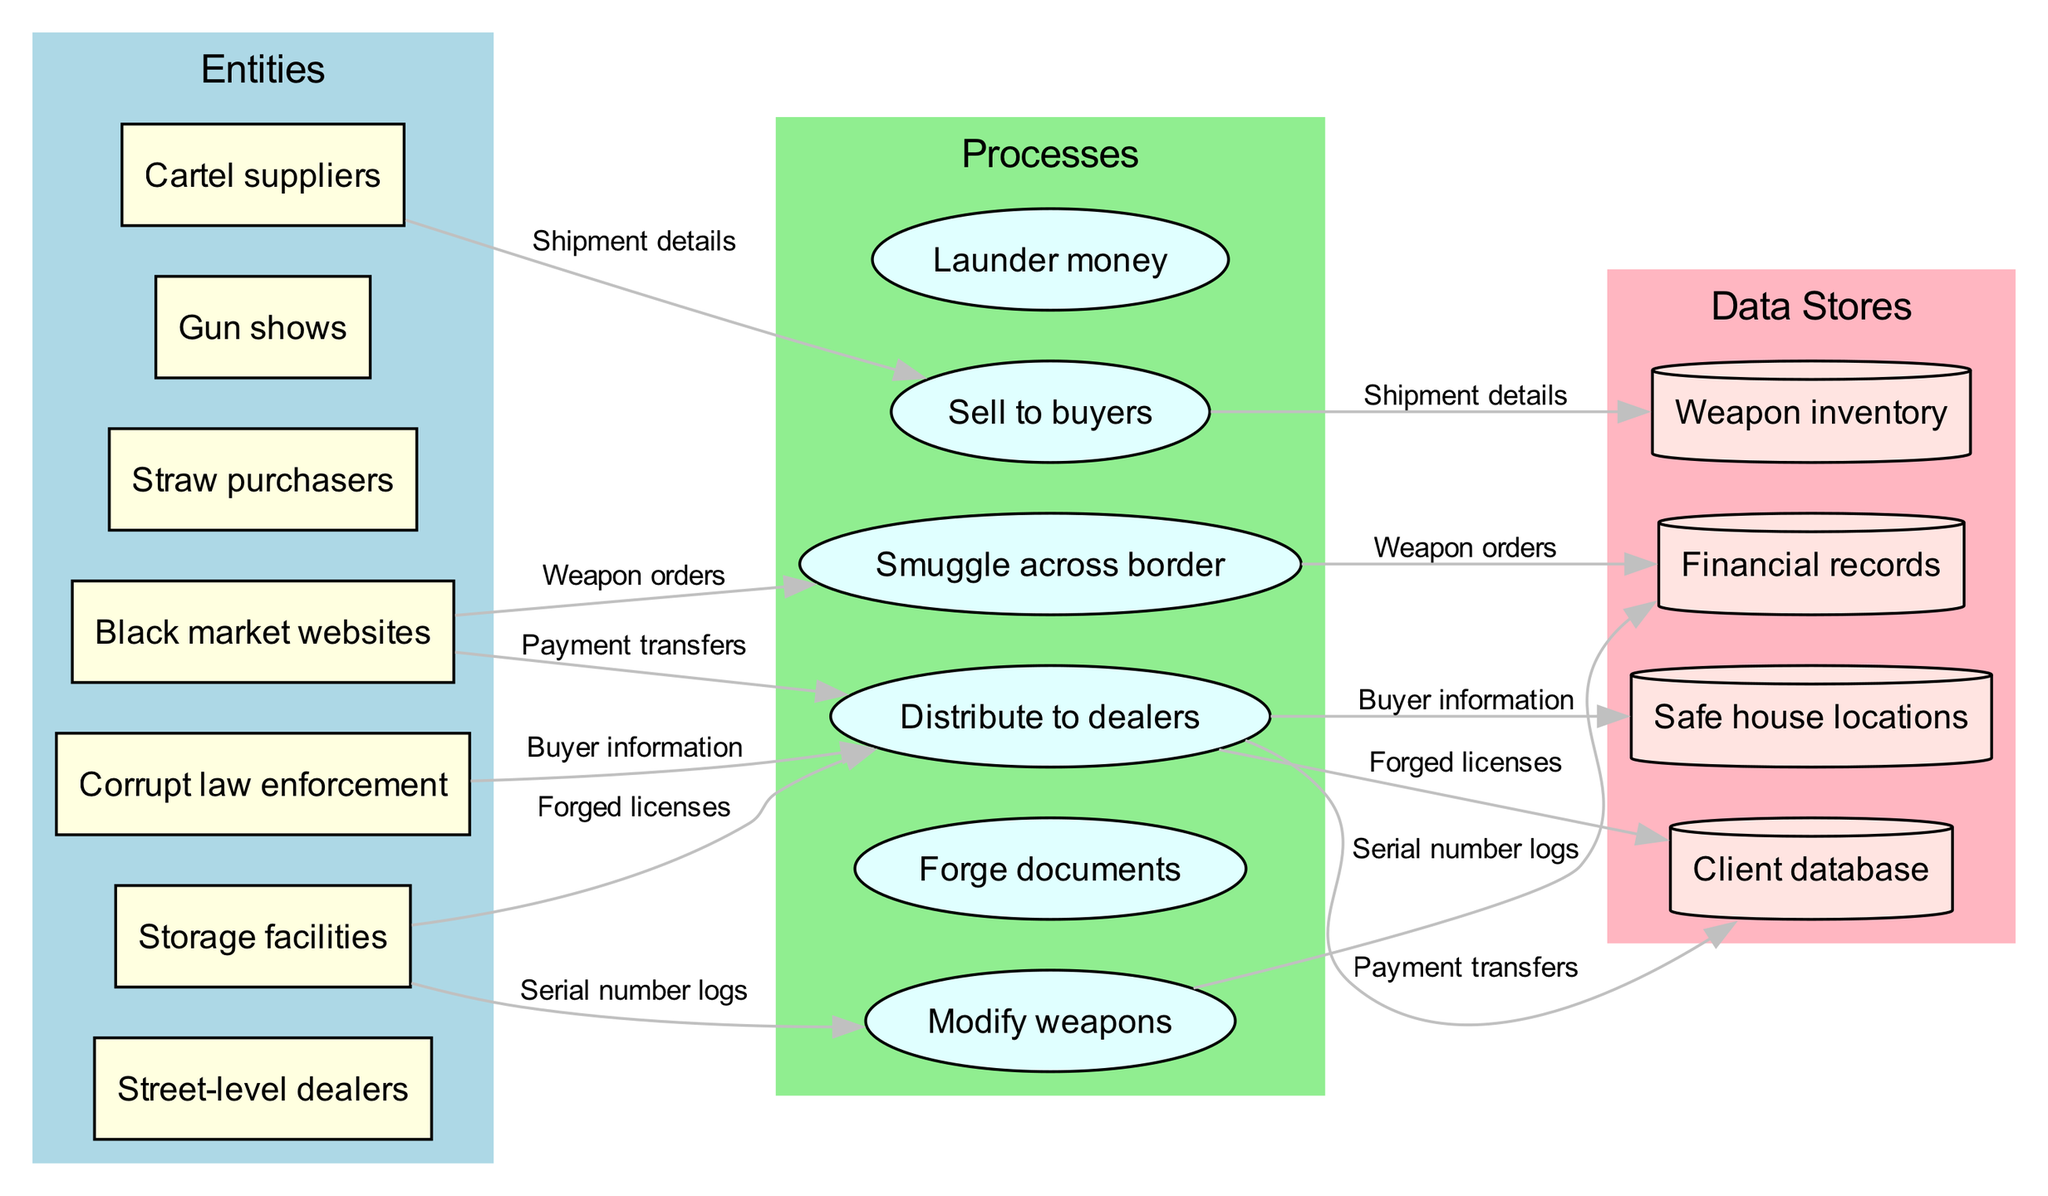What is the total number of entities in the diagram? The diagram lists the entities section, where six distinct entities are identified: Street-level dealers, Cartel suppliers, Corrupt law enforcement, Black market websites, Straw purchasers, and Gun shows. Counting them gives a total of six entities.
Answer: 6 What process is linked to 'Payment transfers'? To find the process linked to 'Payment transfers', we look at the data flow connections in the diagram. 'Payment transfers' connects to one of the processes, which is determined by examining the connections. In this case, it connects to 'Launder money'.
Answer: Launder money Which data store holds 'Buyer information'? Looking at the datastores, 'Buyer information' is one of the data flows that link to a specific datastore. By examining the different datastores in the diagram, 'Buyer information' connects to the 'Client database'.
Answer: Client database How many processes are shown in the diagram? The diagram includes a separate section for processes which lists five processes: Smuggle across border, Forge documents, Modify weapons, Distribute to dealers, and Sell to buyers. Counting these gives a total.
Answer: 5 What is the relationship between 'Storage facilities' and 'Distribute to dealers'? To understand the relationship, we need to look at the data flows and connections in the diagram. 'Storage facilities' is an entity and receives outputs from processes. 'Distribute to dealers' is a process that will send data flows to the 'Street-level dealers', but does not directly connect back to 'Storage facilities'. Therefore, they are indirectly related through the distribution chain.
Answer: Indirectly related Which entities are associated with 'Serial number logs'? 'Serial number logs' is a data flow from the process that requires tracking of weapons, linking it back to the processes that include weapon modifications and distribution. Hence, we assess which entities contribute to that flow. In this case, 'Cartel suppliers' and 'Street-level dealers' are the most likely entities connected to 'Serial number logs'.
Answer: Cartel suppliers, Street-level dealers How many data flows are present in the diagram? The diagram features a section for data flows, which lists a total of six distinct flows: Weapon orders, Payment transfers, Shipment details, Forged licenses, Serial number logs, and Buyer information. Counting these gives us the final number of flows.
Answer: 6 What process is immediately after 'Smuggle across border'? To find which process follows 'Smuggle across border', we need to examine the flow of the diagram. The connection will lead to another process based on the direction of the arrows. In the diagram, 'Smuggle across border' leads directly to 'Forge documents'.
Answer: Forge documents Which datastore is used for financial tracking? The data store used for tracking financial details is located in the data store section of the diagram. The store related to financial transactions is explicitly labeled 'Financial records'. Thus, it serves as a repository for tracking all payment-related information.
Answer: Financial records What kind of processes are represented in the diagram? In the processes section, each listed process represents actions related to illegal activities. They include smuggling, document forgery, weapon modification, drug distribution, selling, and money laundering. Therefore, they focus on illicit actions within the context of firearm acquisition and distribution.
Answer: Illicit actions 